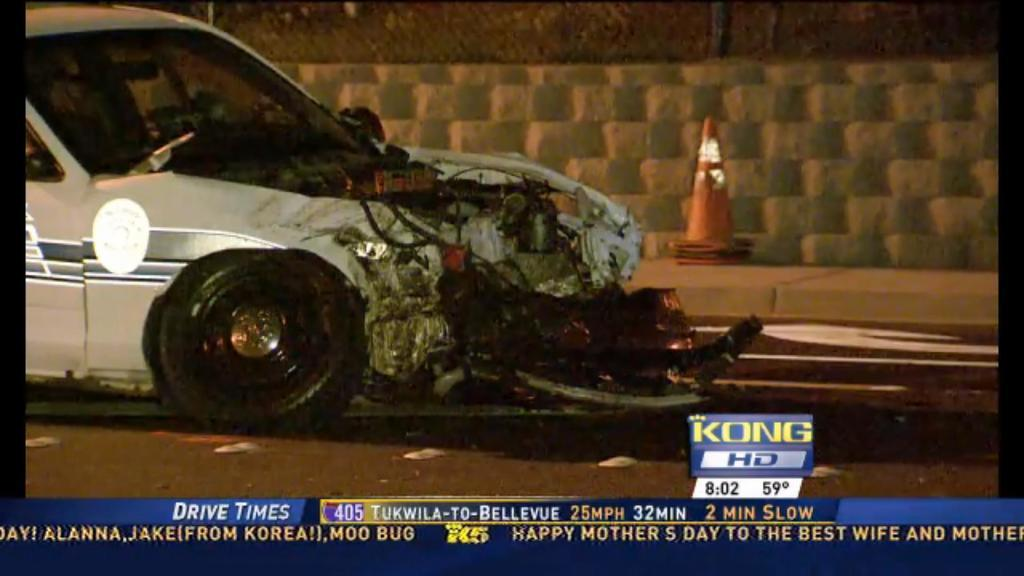<image>
Describe the image concisely. A screen showing a car with its front end destroyed with a banner reading Drive Times underneath. 